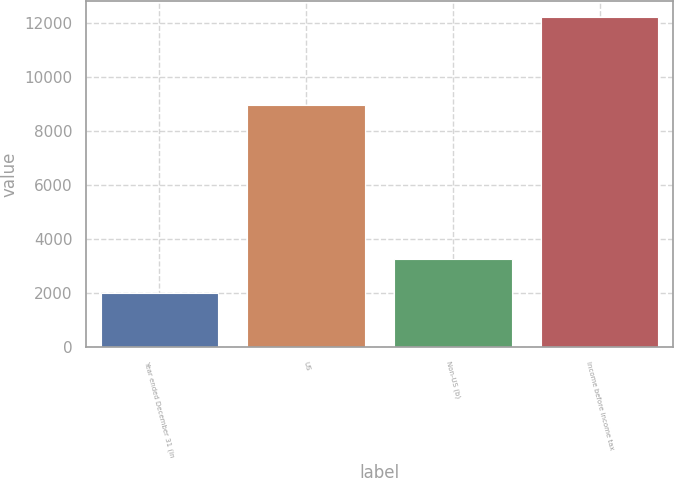Convert chart to OTSL. <chart><loc_0><loc_0><loc_500><loc_500><bar_chart><fcel>Year ended December 31 (in<fcel>US<fcel>Non-US (b)<fcel>Income before income tax<nl><fcel>2005<fcel>8959<fcel>3256<fcel>12215<nl></chart> 